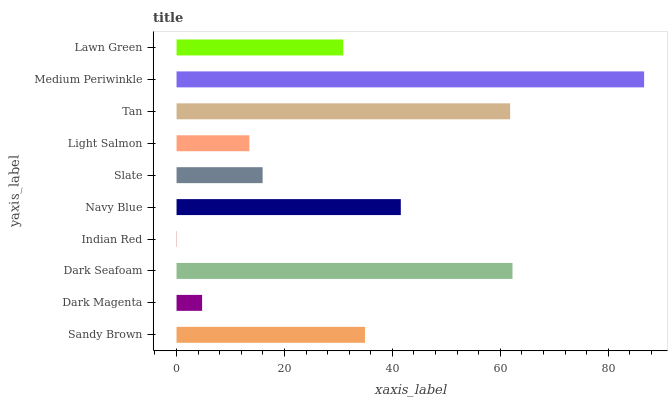Is Indian Red the minimum?
Answer yes or no. Yes. Is Medium Periwinkle the maximum?
Answer yes or no. Yes. Is Dark Magenta the minimum?
Answer yes or no. No. Is Dark Magenta the maximum?
Answer yes or no. No. Is Sandy Brown greater than Dark Magenta?
Answer yes or no. Yes. Is Dark Magenta less than Sandy Brown?
Answer yes or no. Yes. Is Dark Magenta greater than Sandy Brown?
Answer yes or no. No. Is Sandy Brown less than Dark Magenta?
Answer yes or no. No. Is Sandy Brown the high median?
Answer yes or no. Yes. Is Lawn Green the low median?
Answer yes or no. Yes. Is Slate the high median?
Answer yes or no. No. Is Indian Red the low median?
Answer yes or no. No. 